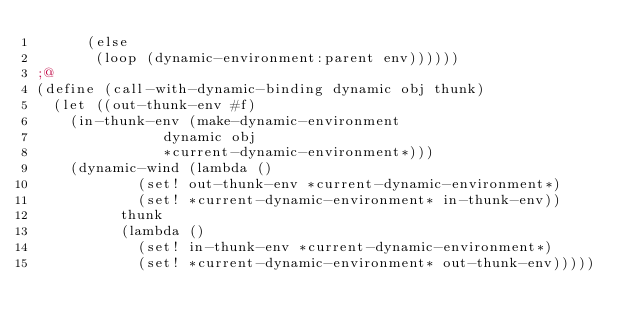Convert code to text. <code><loc_0><loc_0><loc_500><loc_500><_Scheme_>	  (else
	   (loop (dynamic-environment:parent env))))))
;@
(define (call-with-dynamic-binding dynamic obj thunk)
  (let ((out-thunk-env #f)
	(in-thunk-env (make-dynamic-environment
		       dynamic obj
		       *current-dynamic-environment*)))
    (dynamic-wind (lambda ()
		    (set! out-thunk-env *current-dynamic-environment*)
		    (set! *current-dynamic-environment* in-thunk-env))
		  thunk
		  (lambda ()
		    (set! in-thunk-env *current-dynamic-environment*)
		    (set! *current-dynamic-environment* out-thunk-env)))))
</code> 